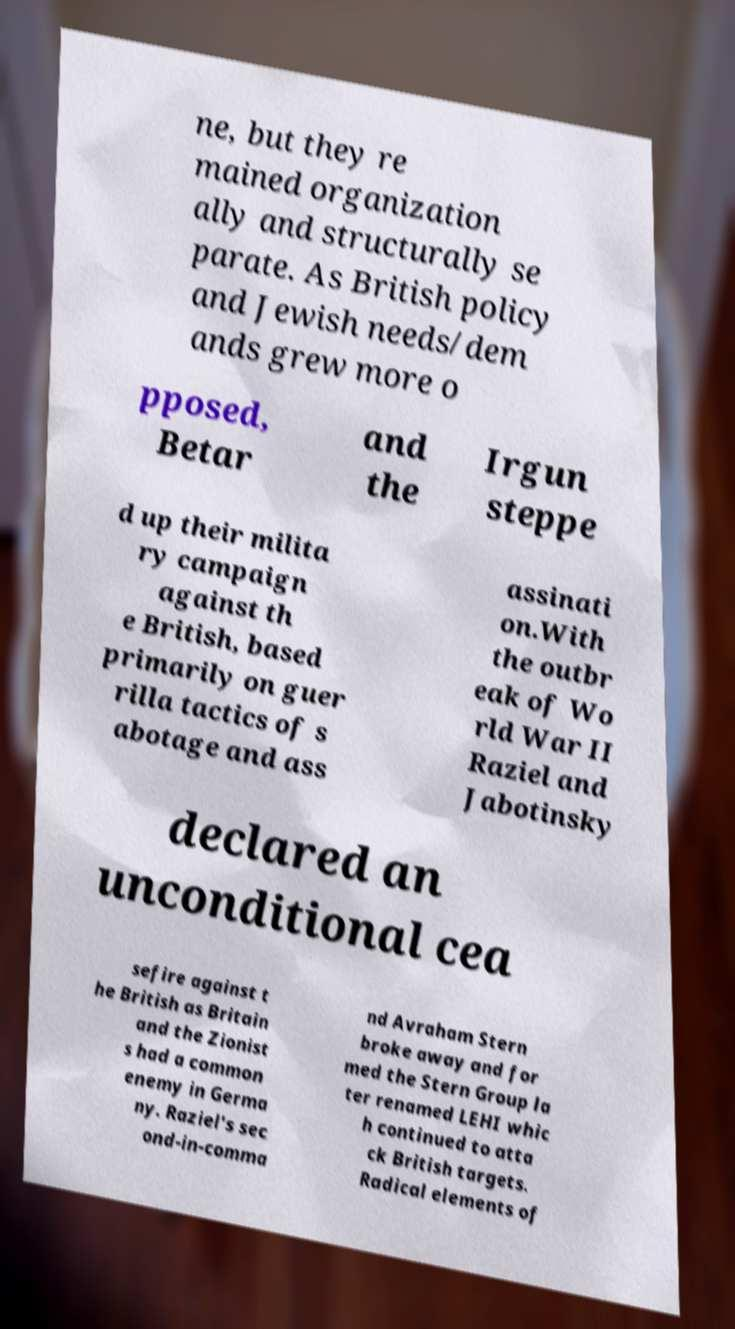There's text embedded in this image that I need extracted. Can you transcribe it verbatim? ne, but they re mained organization ally and structurally se parate. As British policy and Jewish needs/dem ands grew more o pposed, Betar and the Irgun steppe d up their milita ry campaign against th e British, based primarily on guer rilla tactics of s abotage and ass assinati on.With the outbr eak of Wo rld War II Raziel and Jabotinsky declared an unconditional cea sefire against t he British as Britain and the Zionist s had a common enemy in Germa ny. Raziel's sec ond-in-comma nd Avraham Stern broke away and for med the Stern Group la ter renamed LEHI whic h continued to atta ck British targets. Radical elements of 